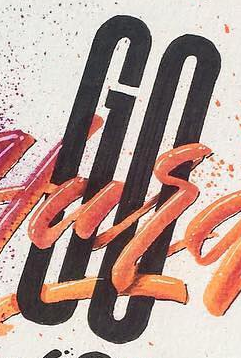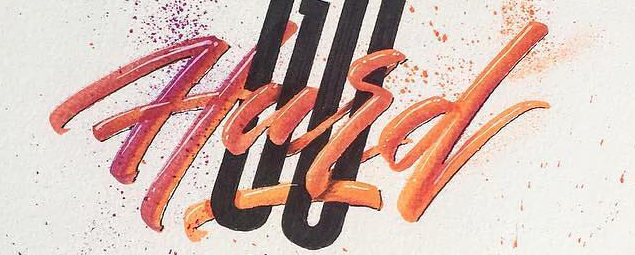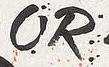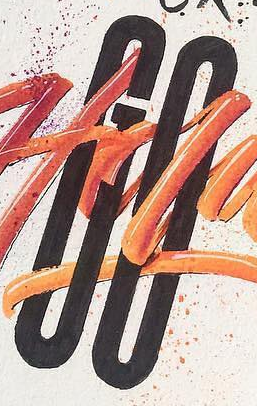What text appears in these images from left to right, separated by a semicolon? GO; Hard; OR; GO 